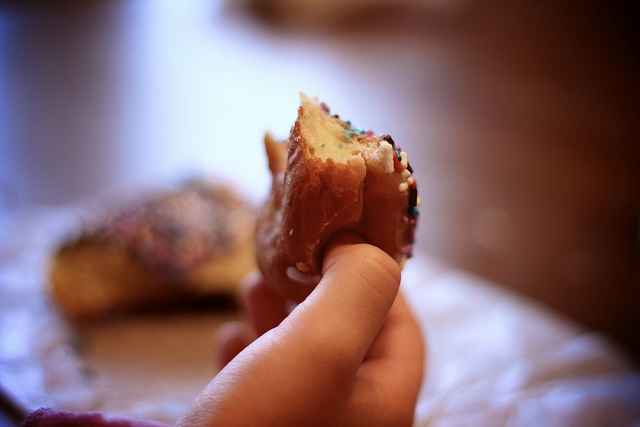Describe the objects in this image and their specific colors. I can see dining table in maroon, lavender, black, darkgray, and brown tones, people in black, brown, maroon, and salmon tones, donut in black, maroon, brown, and darkgray tones, and donut in black, maroon, tan, and brown tones in this image. 